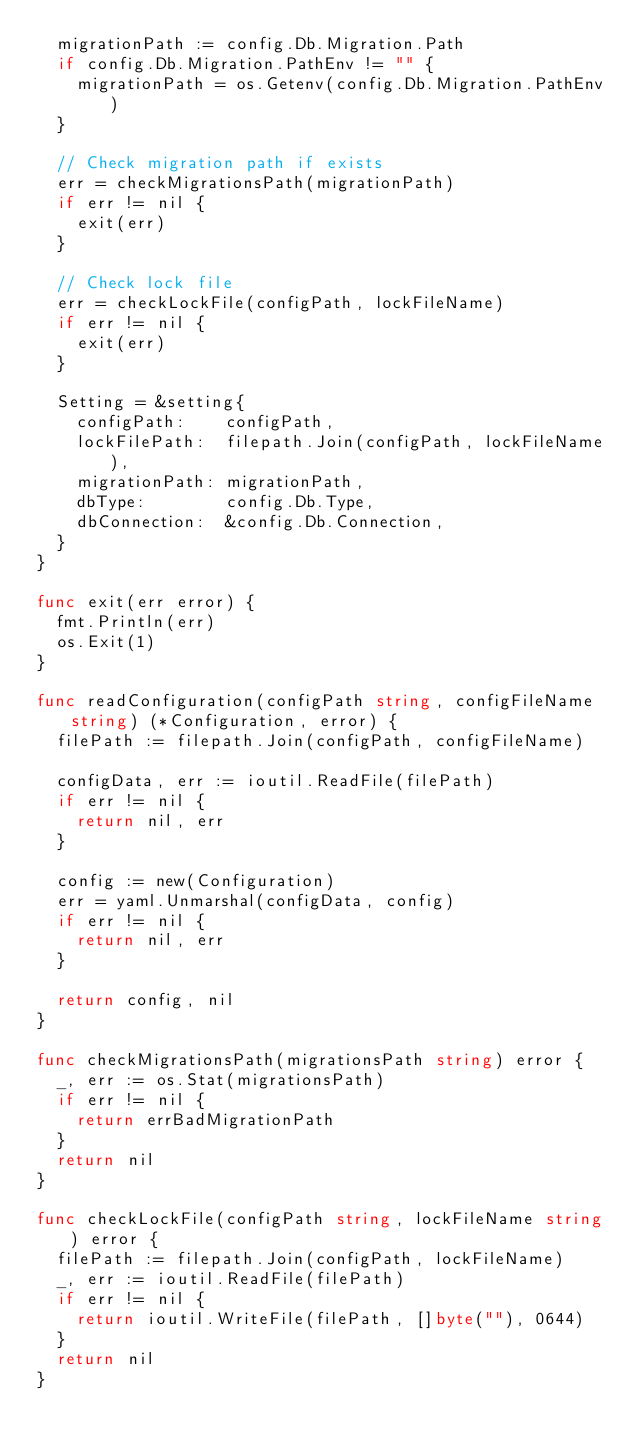Convert code to text. <code><loc_0><loc_0><loc_500><loc_500><_Go_>	migrationPath := config.Db.Migration.Path
	if config.Db.Migration.PathEnv != "" {
		migrationPath = os.Getenv(config.Db.Migration.PathEnv)
	}

	// Check migration path if exists
	err = checkMigrationsPath(migrationPath)
	if err != nil {
		exit(err)
	}

	// Check lock file
	err = checkLockFile(configPath, lockFileName)
	if err != nil {
		exit(err)
	}

	Setting = &setting{
		configPath:    configPath,
		lockFilePath:  filepath.Join(configPath, lockFileName),
		migrationPath: migrationPath,
		dbType:        config.Db.Type,
		dbConnection:  &config.Db.Connection,
	}
}

func exit(err error) {
	fmt.Println(err)
	os.Exit(1)
}

func readConfiguration(configPath string, configFileName string) (*Configuration, error) {
	filePath := filepath.Join(configPath, configFileName)

	configData, err := ioutil.ReadFile(filePath)
	if err != nil {
		return nil, err
	}

	config := new(Configuration)
	err = yaml.Unmarshal(configData, config)
	if err != nil {
		return nil, err
	}

	return config, nil
}

func checkMigrationsPath(migrationsPath string) error {
	_, err := os.Stat(migrationsPath)
	if err != nil {
		return errBadMigrationPath
	}
	return nil
}

func checkLockFile(configPath string, lockFileName string) error {
	filePath := filepath.Join(configPath, lockFileName)
	_, err := ioutil.ReadFile(filePath)
	if err != nil {
		return ioutil.WriteFile(filePath, []byte(""), 0644)
	}
	return nil
}
</code> 